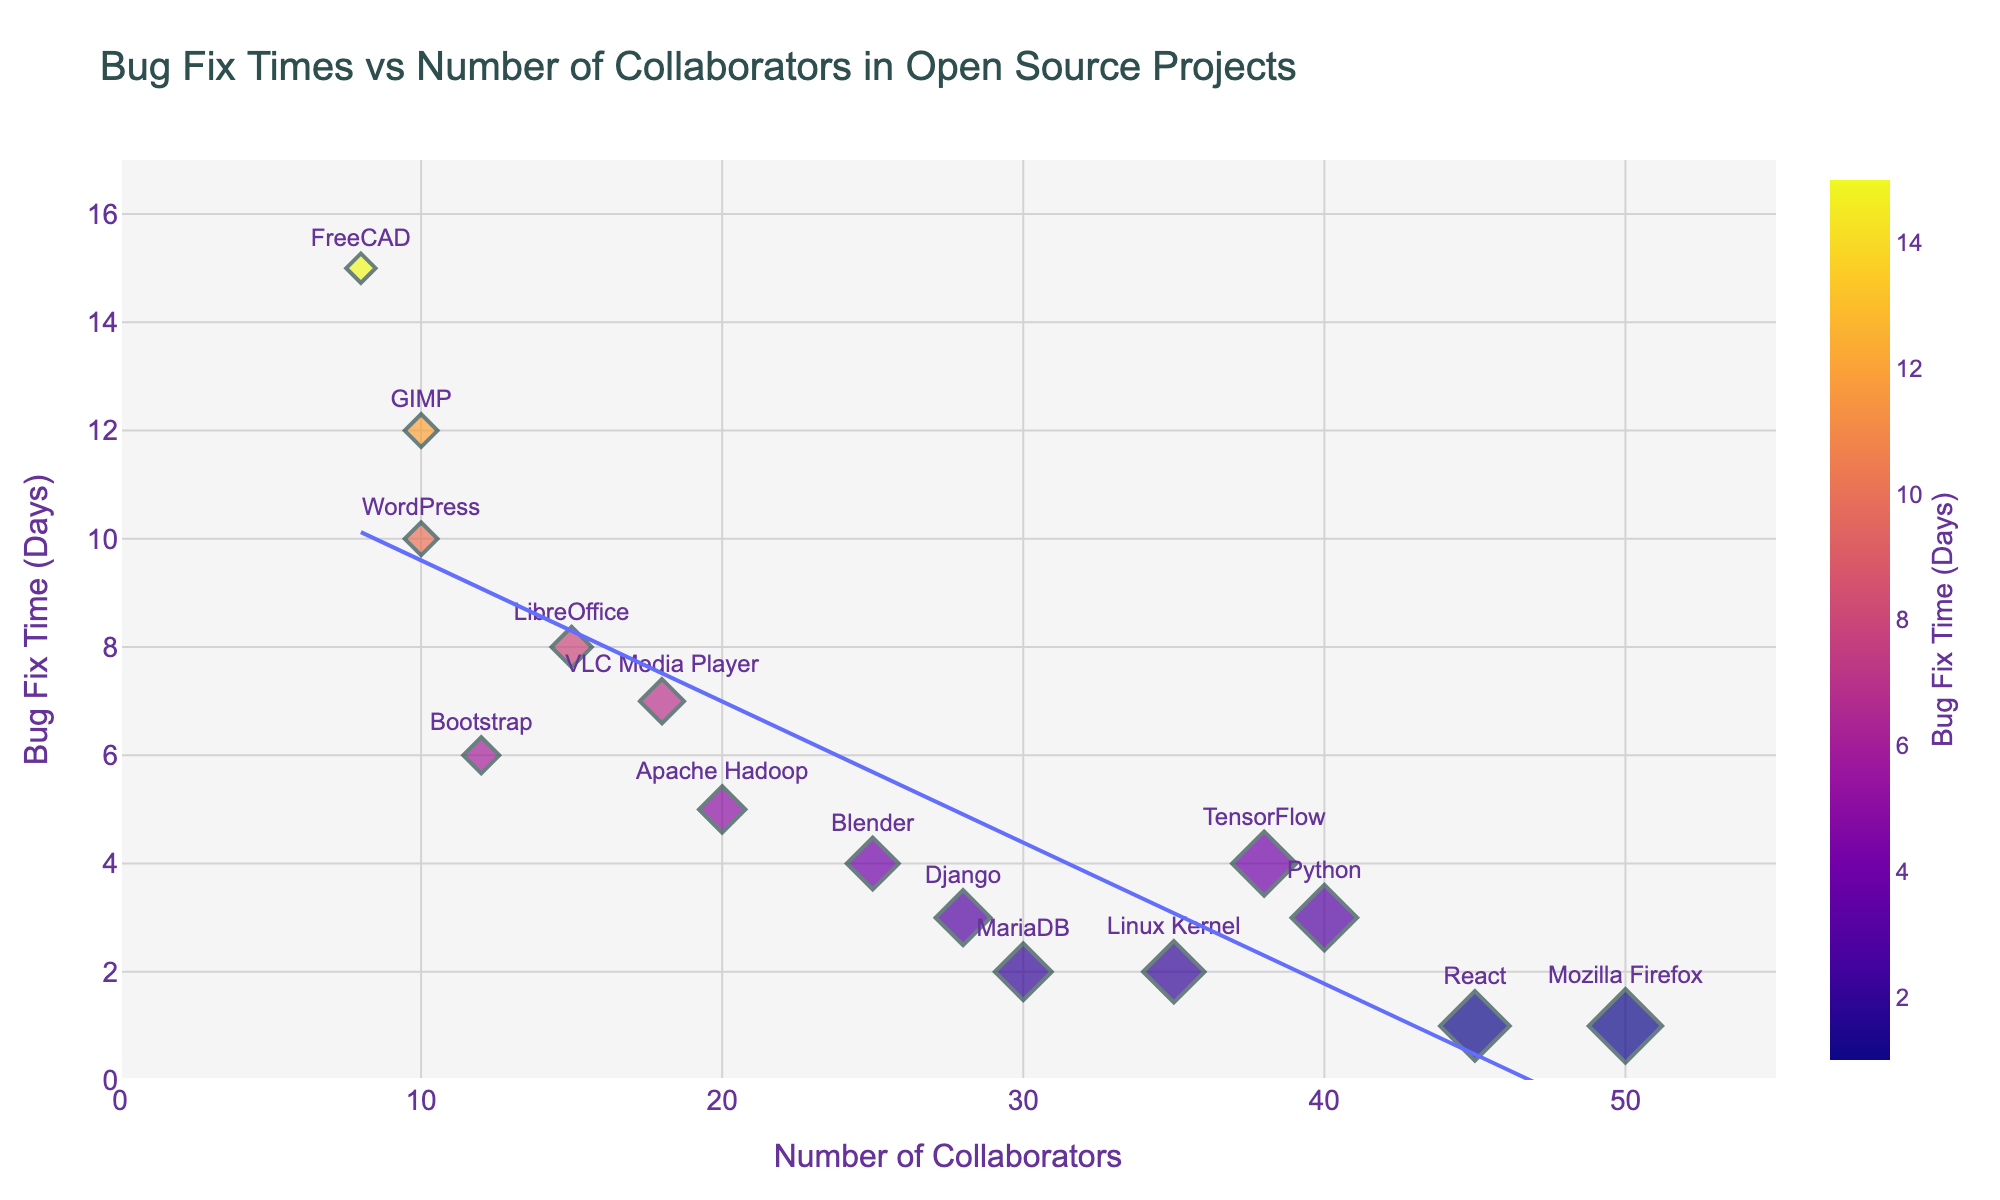How many projects have more than 30 collaborators? Visual inspection of the x-axis and filtering out points where the number of collaborators is greater than 30. The highlighted projects are Linux Kernel, Mozilla Firefox, Python, React, MariaDB, and TensorFlow.
Answer: 6 Which project has the longest bug fix time? By looking at the vertical position of the points (y-axis), the highest positioned point is FreeCAD, which indicates the longest bug fix time.
Answer: FreeCAD What is the bug fix time for Blender? By identifying Blender on the scatter plot and looking at its y-axis position, Blender is found at 4 days.
Answer: 4 days Is there a general trend between the number of collaborators and bug fix time? A downward trend line is added to the plot, showing that as the number of collaborators increases, the bug fix time tends to decrease. The presence of a negative slope in the trend line confirms the negative correlation.
Answer: Decreasing trend Which has more collaborators, Blender or VLC Media Player? By comparing the x-axis positions of Blender and VLC Media Player, Blender has 25 collaborators while VLC Media Player has 18.
Answer: Blender What is the average bug fix time for projects with less than 15 collaborators? First, identify the projects with fewer than 15 collaborators (LibreOffice, GIMP, WordPress, FreeCAD, Bootstrap), then sum their bug fix times: 8 + 12 + 10 + 15 + 6 = 51. There are 5 such projects, so the average is 51/5.
Answer: 10.2 days Which project with more than 35 collaborators has the shortest bug fix time? Identify projects with more than 35 collaborators (Linux Kernel, Mozilla Firefox, Python, React, TensorFlow), then find the one with the lowest y-value. Mozilla Firefox and React both have 1 day.
Answer: Mozilla Firefox and React Does GIMP have a higher bug fix time than WordPress? By comparing the y-axis positions of GIMP and WordPress, GIMP is at 12 days and WordPress is at 10 days.
Answer: Yes What is the median bug fix time for all the projects? Order the bug fix times: 1, 1, 2, 2, 3, 3, 4, 4, 5, 6, 7, 8, 10, 12, 15. The median is the middle value (8th in the list).
Answer: 4 days How many projects have a bug fix time less than or equal to 3 days? Count the points on the plot where the vertical position (y-value) is 3 or less. The projects are Linux Kernel, Mozilla Firefox, Python, Django, and MariaDB.
Answer: 5 